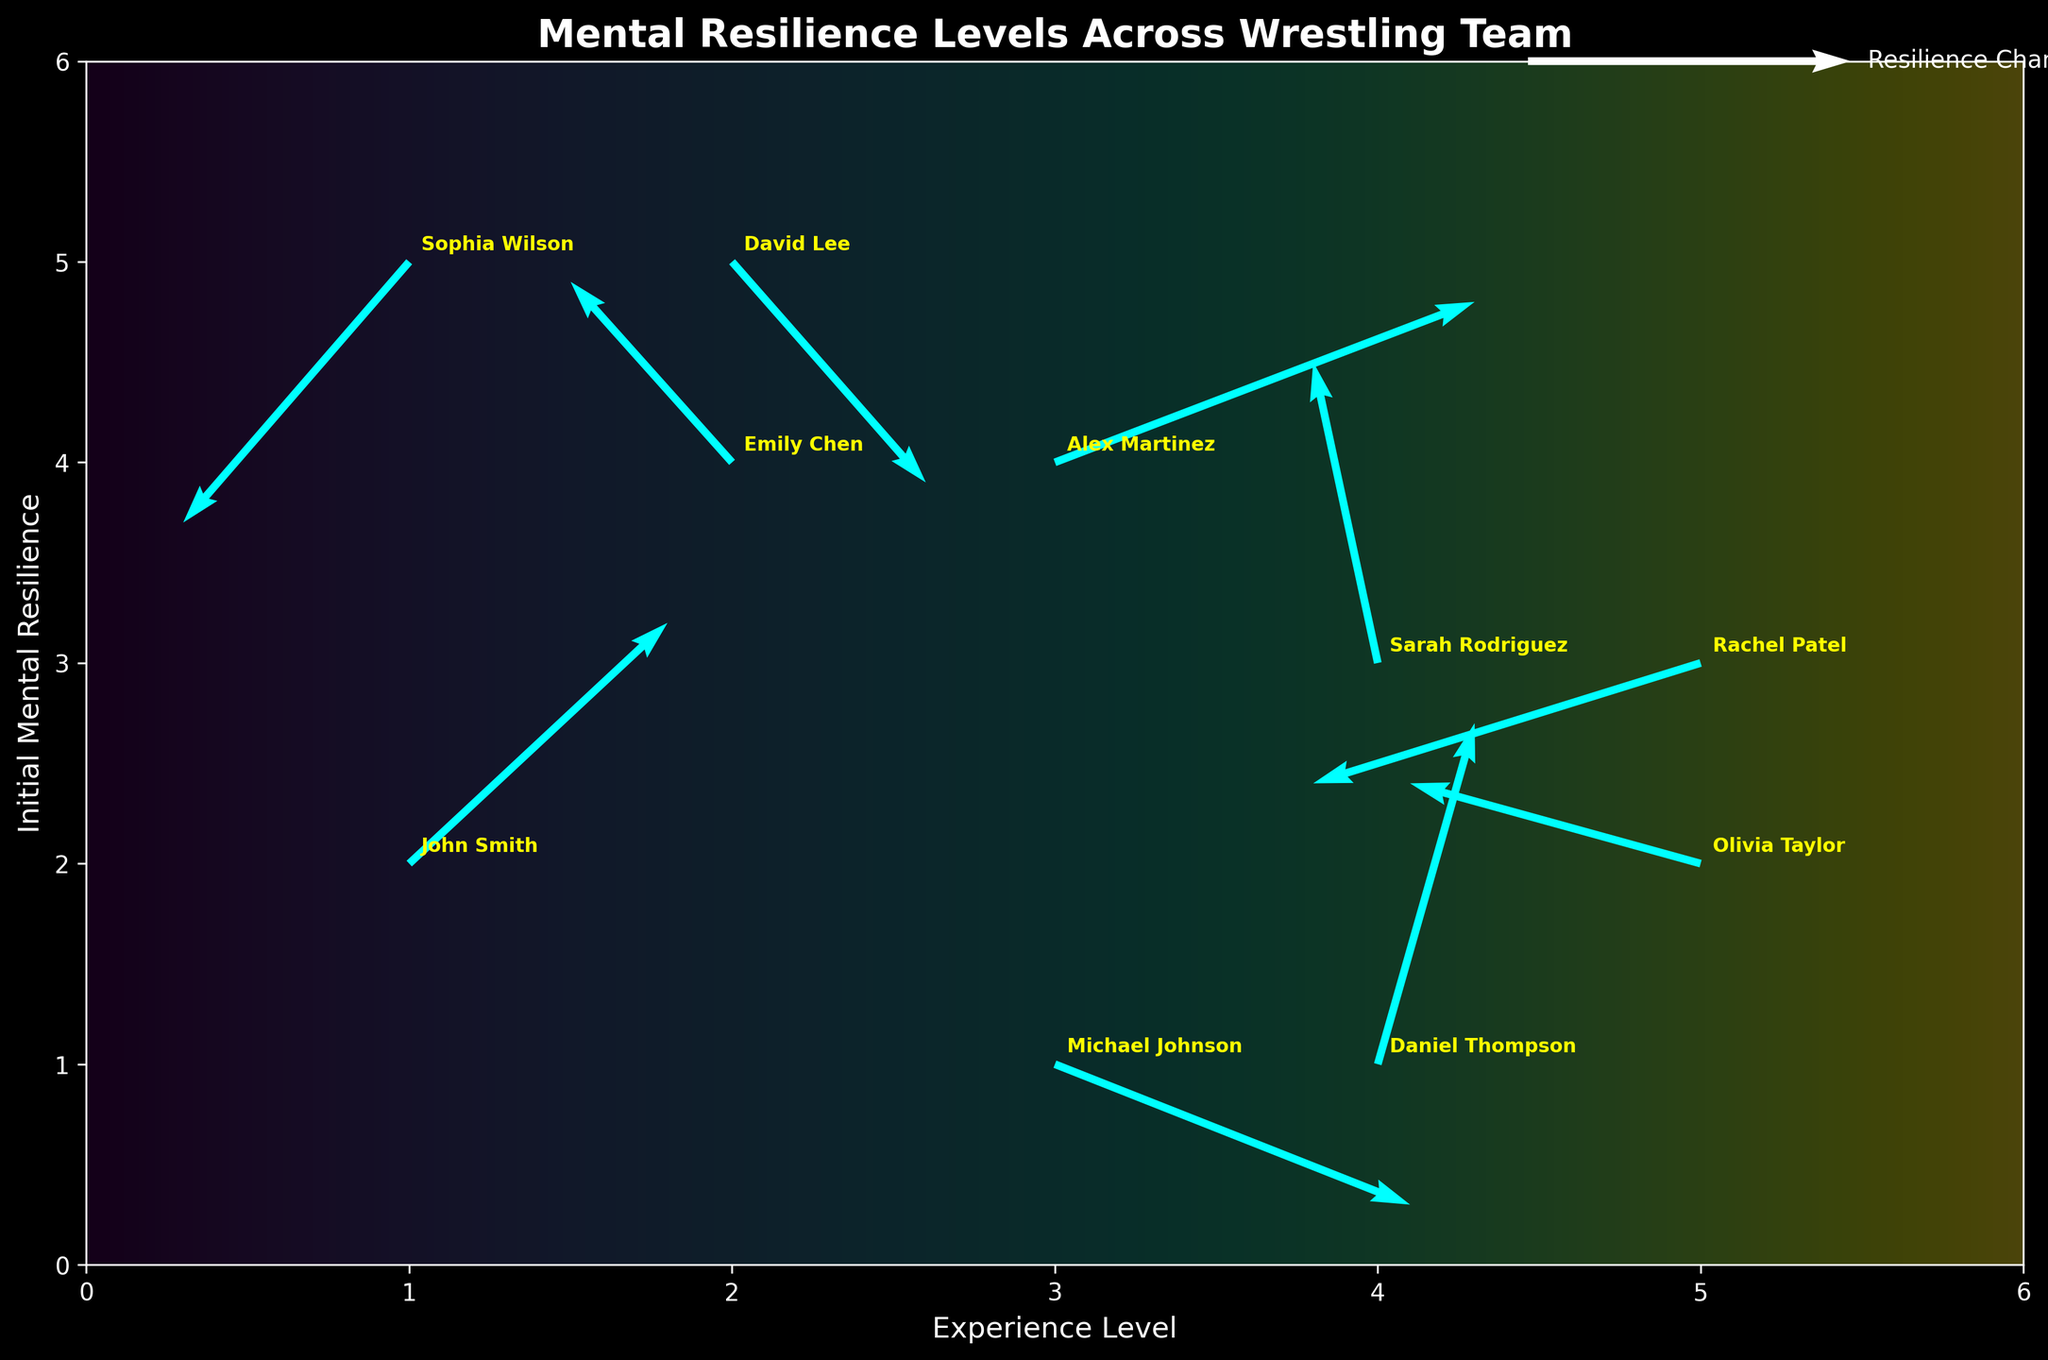what is the title of the plot? The title can be observed at the top of the plot in larger text.
Answer: "Mental Resilience Levels Across Wrestling Team" How many data points are shown on the quiver plot? Count each arrow or starting point marked on the plot.
Answer: 10 What color are the arrows representing changes in resilience? Observe the color of the arrows in the plot.
Answer: Cyan Which wrestler starts at the highest initial mental resilience level? Look for the highest Y-axis value and identify the wrestler's name.
Answer: David Lee Which wrestler shows the greatest increase in mental resilience? Identify the arrow with the largest upward length (V value) and refer to the corresponding name.
Answer: Daniel Thompson What is the experience level of Rachel Patel? Identify Rachel Patel's starting position on the X-axis by matching her name.
Answer: 5 Who shows a decrease in mental resilience despite having a high initial level? Look for negative V vectors from high Y starting points and identify the wrestler's name.
Answer: David Lee What is the average change in resilience for Emily Chen and Michael Johnson? Calculate the average of V values for Emily Chen (0.9) and Michael Johnson (-0.7). (0.9 + (-0.7))/2 = 0.1
Answer: 0.1 Which wrestlers have experienced a decrease in mental resilience? Identify negative V values and list corresponding names.
Answer: Emily Chen, Michael Johnson, David Lee, Olivia Taylor, Rachel Patel, Sophia Wilson Compare the resilience changes between Alex Martinez and Michael Johnson. Who showed a greater increase? Compare the V values and note that Alex Martinez has 0.8 and Michael Johnson has -0.7.
Answer: Alex Martinez 